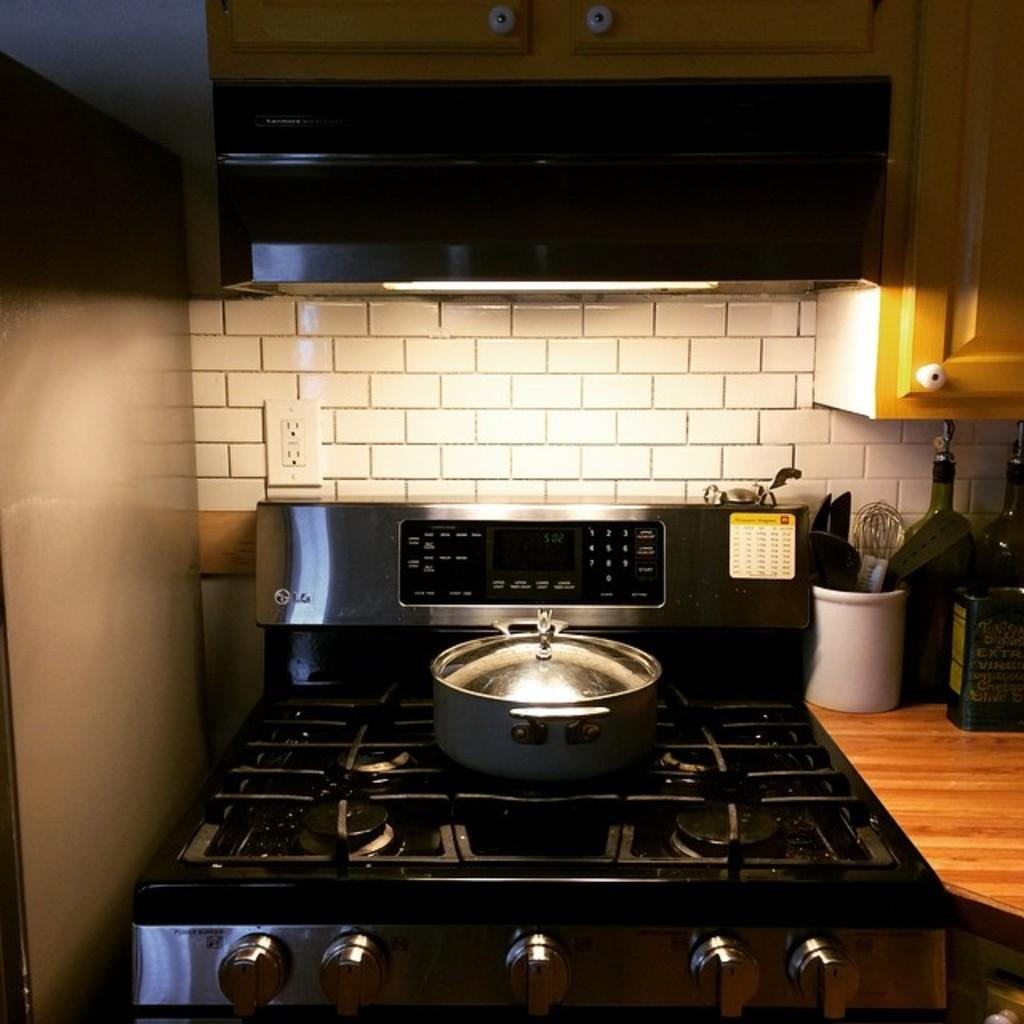What is on the stove in the image? There is a vessel on the stove in the image. What can be seen on the right side of the image? There are bottles on the right side of the image. What is located in the middle of the image? There is a light in the middle of the image. What type of hat is the mom wearing in the image? There is no mom or hat present in the image. How many bottles are visible in the image? The fact only mentions that there are bottles on the right side of the image, but it does not specify the exact number. 